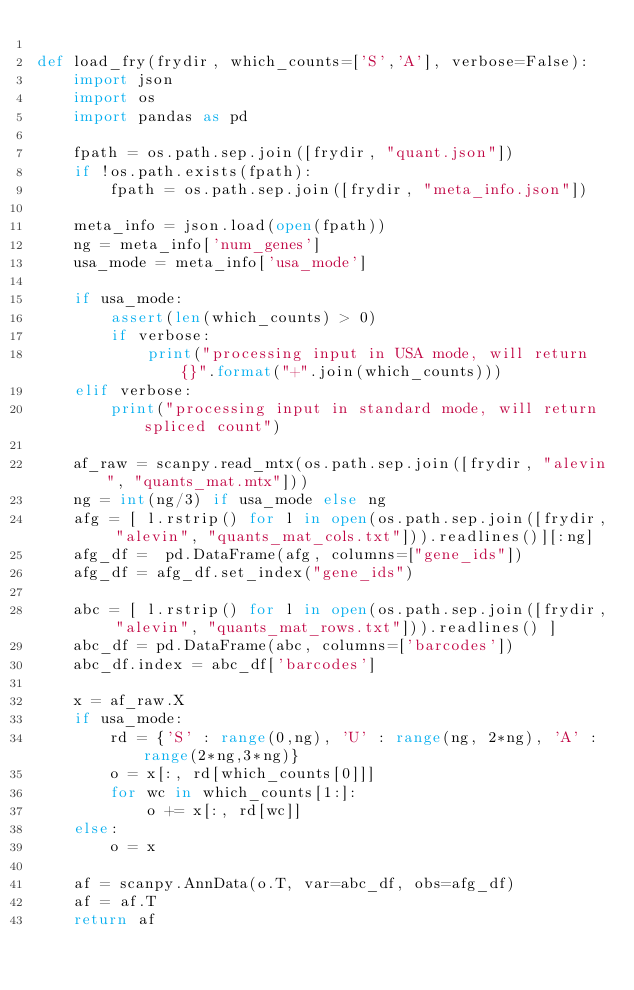Convert code to text. <code><loc_0><loc_0><loc_500><loc_500><_Python_>
def load_fry(frydir, which_counts=['S','A'], verbose=False):
    import json
    import os
    import pandas as pd
    
    fpath = os.path.sep.join([frydir, "quant.json"])
    if !os.path.exists(fpath):
        fpath = os.path.sep.join([frydir, "meta_info.json"])

    meta_info = json.load(open(fpath))
    ng = meta_info['num_genes']
    usa_mode = meta_info['usa_mode']

    if usa_mode:
        assert(len(which_counts) > 0)
        if verbose:
            print("processing input in USA mode, will return {}".format("+".join(which_counts)))
    elif verbose:
        print("processing input in standard mode, will return spliced count")

    af_raw = scanpy.read_mtx(os.path.sep.join([frydir, "alevin", "quants_mat.mtx"]))
    ng = int(ng/3) if usa_mode else ng
    afg = [ l.rstrip() for l in open(os.path.sep.join([frydir, "alevin", "quants_mat_cols.txt"])).readlines()][:ng]
    afg_df =  pd.DataFrame(afg, columns=["gene_ids"])
    afg_df = afg_df.set_index("gene_ids")
    
    abc = [ l.rstrip() for l in open(os.path.sep.join([frydir, "alevin", "quants_mat_rows.txt"])).readlines() ]
    abc_df = pd.DataFrame(abc, columns=['barcodes'])
    abc_df.index = abc_df['barcodes']
    
    x = af_raw.X
    if usa_mode:
        rd = {'S' : range(0,ng), 'U' : range(ng, 2*ng), 'A' : range(2*ng,3*ng)}
        o = x[:, rd[which_counts[0]]]
        for wc in which_counts[1:]:
            o += x[:, rd[wc]]
    else:
        o = x
        
    af = scanpy.AnnData(o.T, var=abc_df, obs=afg_df)
    af = af.T
    return af
</code> 